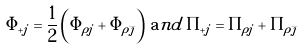Convert formula to latex. <formula><loc_0><loc_0><loc_500><loc_500>\Phi _ { + j } = \frac { 1 } { 2 } \left ( \Phi _ { \rho j } + \Phi _ { \rho \bar { \jmath } } \right ) \, { \mathrm a n d } \, \Pi _ { + j } = \Pi _ { \rho j } + \Pi _ { \rho \bar { \jmath } }</formula> 